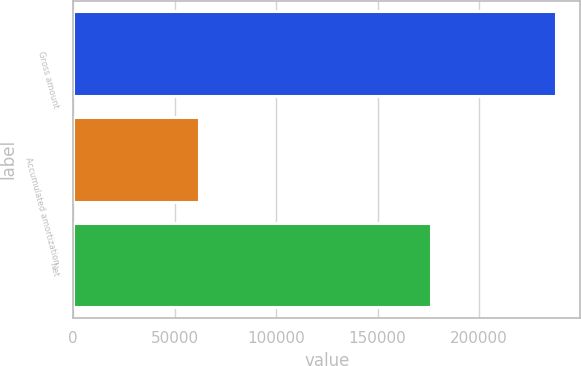Convert chart. <chart><loc_0><loc_0><loc_500><loc_500><bar_chart><fcel>Gross amount<fcel>Accumulated amortization<fcel>Net<nl><fcel>238064<fcel>61942<fcel>176122<nl></chart> 